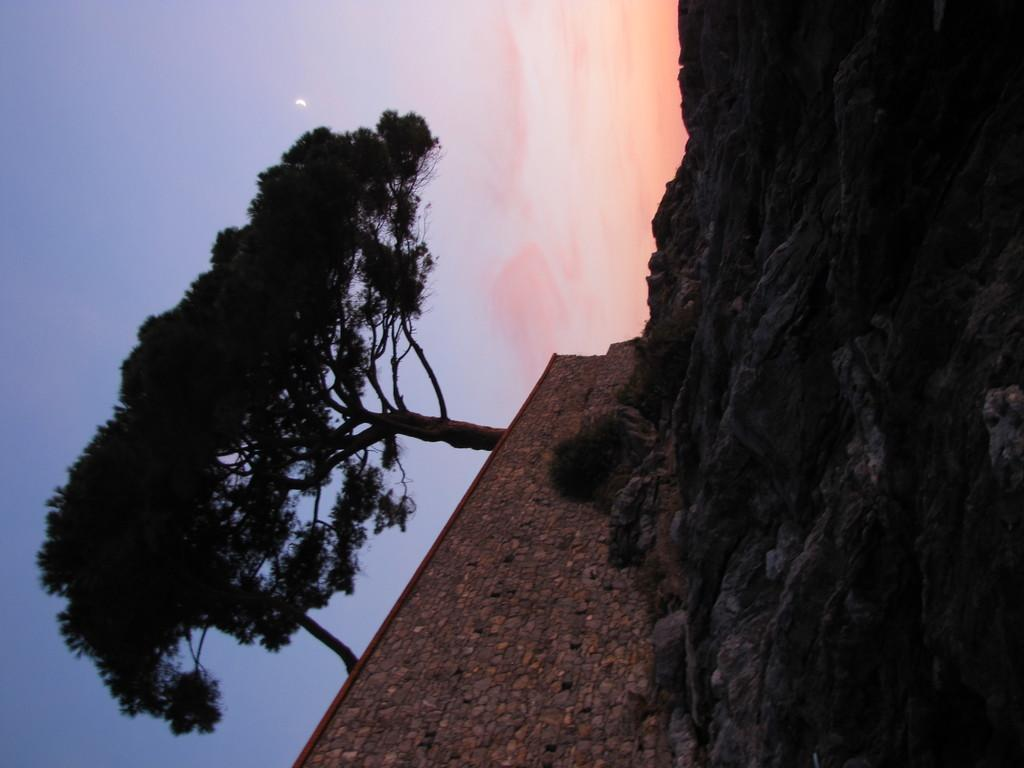What type of natural elements can be seen in the image? There are rocks in the image. What type of man-made structure is present in the image? There is a wall in the image. What type of vegetation is visible in the image? There are trees in the image. How many steps are there in the image? There is no mention of steps in the image; it features rocks, a wall, and trees. What type of brick is used to construct the wall in the image? There is no specific information about the type of brick used to construct the wall in the image. 